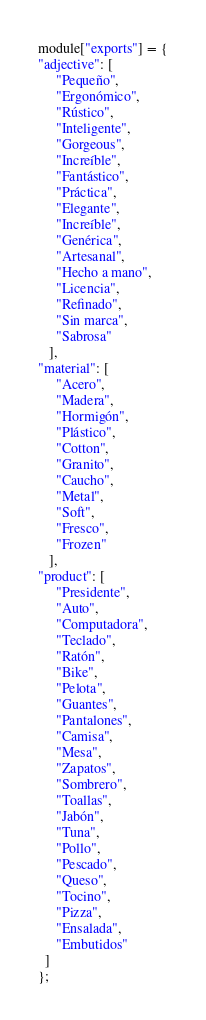Convert code to text. <code><loc_0><loc_0><loc_500><loc_500><_JavaScript_>module["exports"] = {
"adjective": [
     "Pequeño",
     "Ergonómico",
     "Rústico",
     "Inteligente",
     "Gorgeous",
     "Increíble",
     "Fantástico",
     "Práctica",
     "Elegante",
     "Increíble",
     "Genérica",
     "Artesanal",
     "Hecho a mano",
     "Licencia",
     "Refinado",
     "Sin marca",
     "Sabrosa"
   ],
"material": [
     "Acero",
     "Madera",
     "Hormigón",
     "Plástico",
     "Cotton",
     "Granito",
     "Caucho",
     "Metal",
     "Soft",
     "Fresco",
     "Frozen"
   ],
"product": [
     "Presidente",
     "Auto",
     "Computadora",
     "Teclado",
     "Ratón",
     "Bike",
     "Pelota",
     "Guantes",
     "Pantalones",
     "Camisa",
     "Mesa",
     "Zapatos",
     "Sombrero",
     "Toallas",
     "Jabón",
     "Tuna",
     "Pollo",
     "Pescado",
     "Queso",
     "Tocino",
     "Pizza",
     "Ensalada",
     "Embutidos"
  ]
};
</code> 